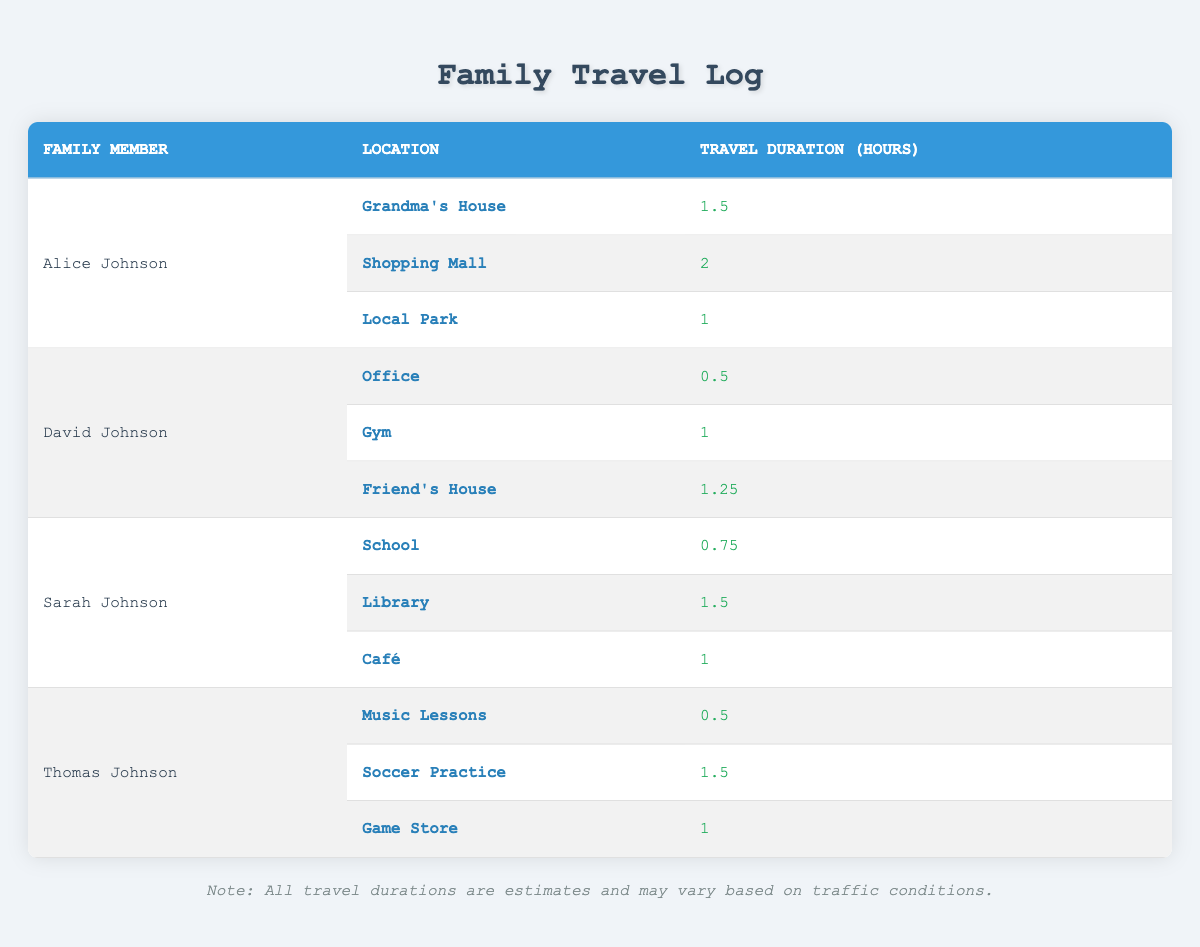What are the total travel hours for Alice Johnson? Alice visited three locations: Grandma's House (1.5 hours), Shopping Mall (2 hours), and Local Park (1 hour). The total is calculated as 1.5 + 2 + 1 = 4.5 hours.
Answer: 4.5 hours Which family member spent the least amount of time traveling? David Johnson spent the least amount of time traveling with 0.5 hours to the Office.
Answer: David Johnson What is the average travel duration for Sarah Johnson? Sarah visited three locations: School (0.75 hours), Library (1.5 hours), and Café (1 hour). The total travel time is 0.75 + 1.5 + 1 = 3.25 hours. The average is 3.25 hours / 3 = 1.08 hours.
Answer: 1.08 hours Did Thomas Johnson visit the Game Store longer than Alice visited Local Park? Thomas spent 1 hour at the Game Store. Alice spent 1 hour at the Local Park, so they are equal. Thus, the answer is no.
Answer: No What is the total travel time for David Johnson and Thomas Johnson combined? David visited three locations which totaled 0.5 + 1 + 1.25 = 2.75 hours. Thomas's total is 0.5 + 1.5 + 1 = 3 hours. Combining both totals gives 2.75 + 3 = 5.75 hours.
Answer: 5.75 hours What location did Sarah Johnson spend the most time visiting? Sarah spent the most time at the Library, which took 1.5 hours.
Answer: Library Is it true that all locations visited by Alice Johnson took more than 1 hour? Alice visited Local Park for 1 hour, which is not more than 1 hour; hence, it is false.
Answer: False Which location did David Johnson spend the most time at and how long? David spent the most time at Friend's House for 1.25 hours.
Answer: Friend's House, 1.25 hours 